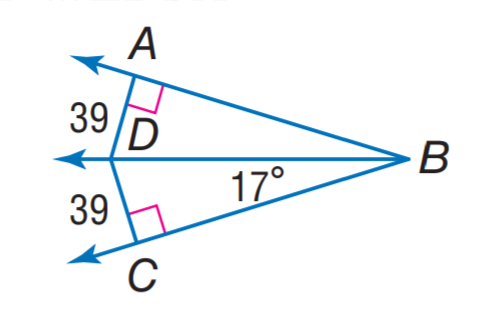Assuming triangle ABC is an isosceles triangle with AB as the base, what is the length of AC compared to AB? Since triangle ABC has two angles of the same measure (both 39 degrees), it is an isosceles triangle with sides AC and BC being equal in length. Without the specific measurements of the sides, we cannot determine the actual length, but we can say that AC is equal in length to BC, and these two sides are likely to be longer than the base AB. 